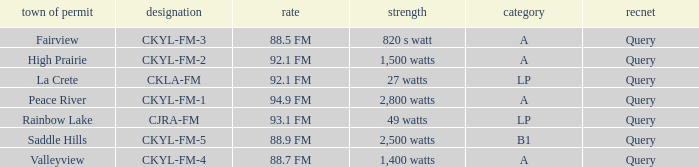What is the power with 88.5 fm frequency 820 s watt. 